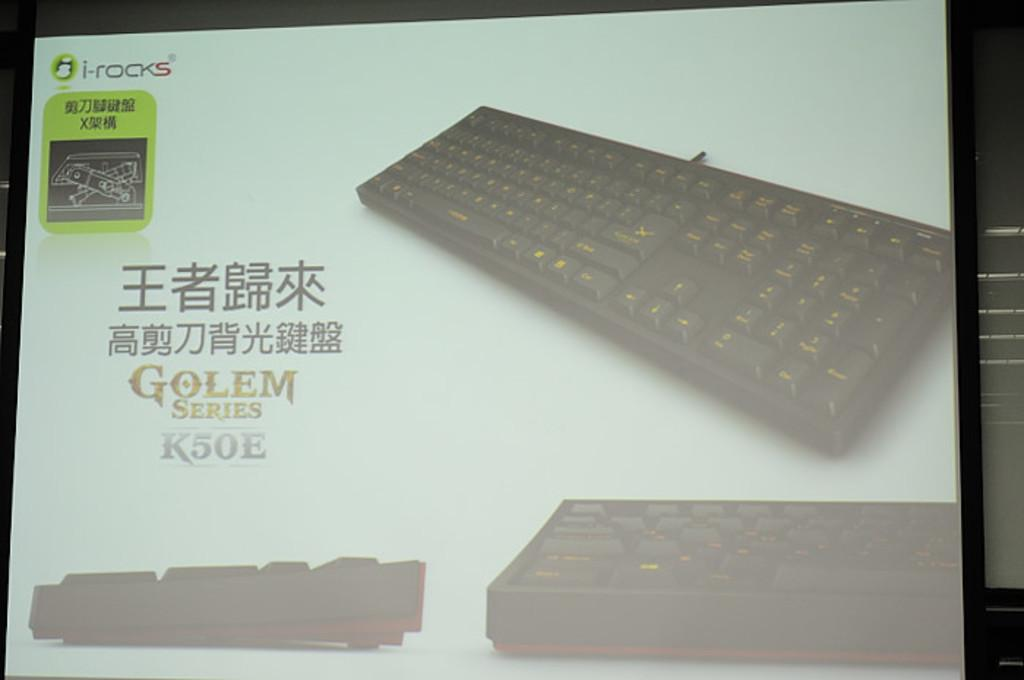<image>
Write a terse but informative summary of the picture. A projector screen is showing a keyboard that says Golem Series K50E. 